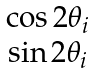Convert formula to latex. <formula><loc_0><loc_0><loc_500><loc_500>\begin{matrix} \cos 2 \theta _ { i } \\ \sin 2 \theta _ { i } \end{matrix}</formula> 